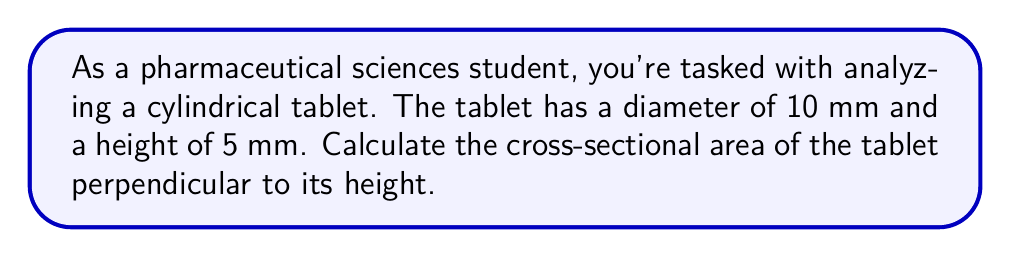Provide a solution to this math problem. To solve this problem, we need to follow these steps:

1) First, let's visualize the tablet:

[asy]
import three;

size(200);
currentprojection=orthographic(4,4,2);

real r = 5;
real h = 5;

draw(surface(circle((0,0,0),r)),blue+opacity(0.5));
draw(surface(circle((0,0,h),r)),blue+opacity(0.5));
draw(surface(cylinder((0,0,0),r,h)),blue+opacity(0.2));

draw((r,0,0)--(r,0,h),dashed);
draw((0,r,0)--(0,r,h),dashed);
draw((-r,0,0)--(-r,0,h),dashed);
draw((0,-r,0)--(0,-r,h),dashed);

label("10 mm", (r/2,-r/2,0), S);
label("5 mm", (r,0,h/2), E);
[/asy]

2) The cross-sectional area of a cylindrical tablet perpendicular to its height is a circle.

3) To find the area of this circular cross-section, we need to use the formula for the area of a circle:

   $$A = \pi r^2$$

   where $A$ is the area and $r$ is the radius of the circle.

4) We're given the diameter of the tablet, which is 10 mm. The radius is half of this:

   $$r = \frac{10}{2} = 5 \text{ mm}$$

5) Now we can substitute this into our formula:

   $$A = \pi (5 \text{ mm})^2$$

6) Let's calculate this:

   $$A = \pi \cdot 25 \text{ mm}^2 = 78.54 \text{ mm}^2$$

7) Rounding to two decimal places, we get our final answer.
Answer: The cross-sectional area of the cylindrical tablet is approximately $78.54 \text{ mm}^2$. 